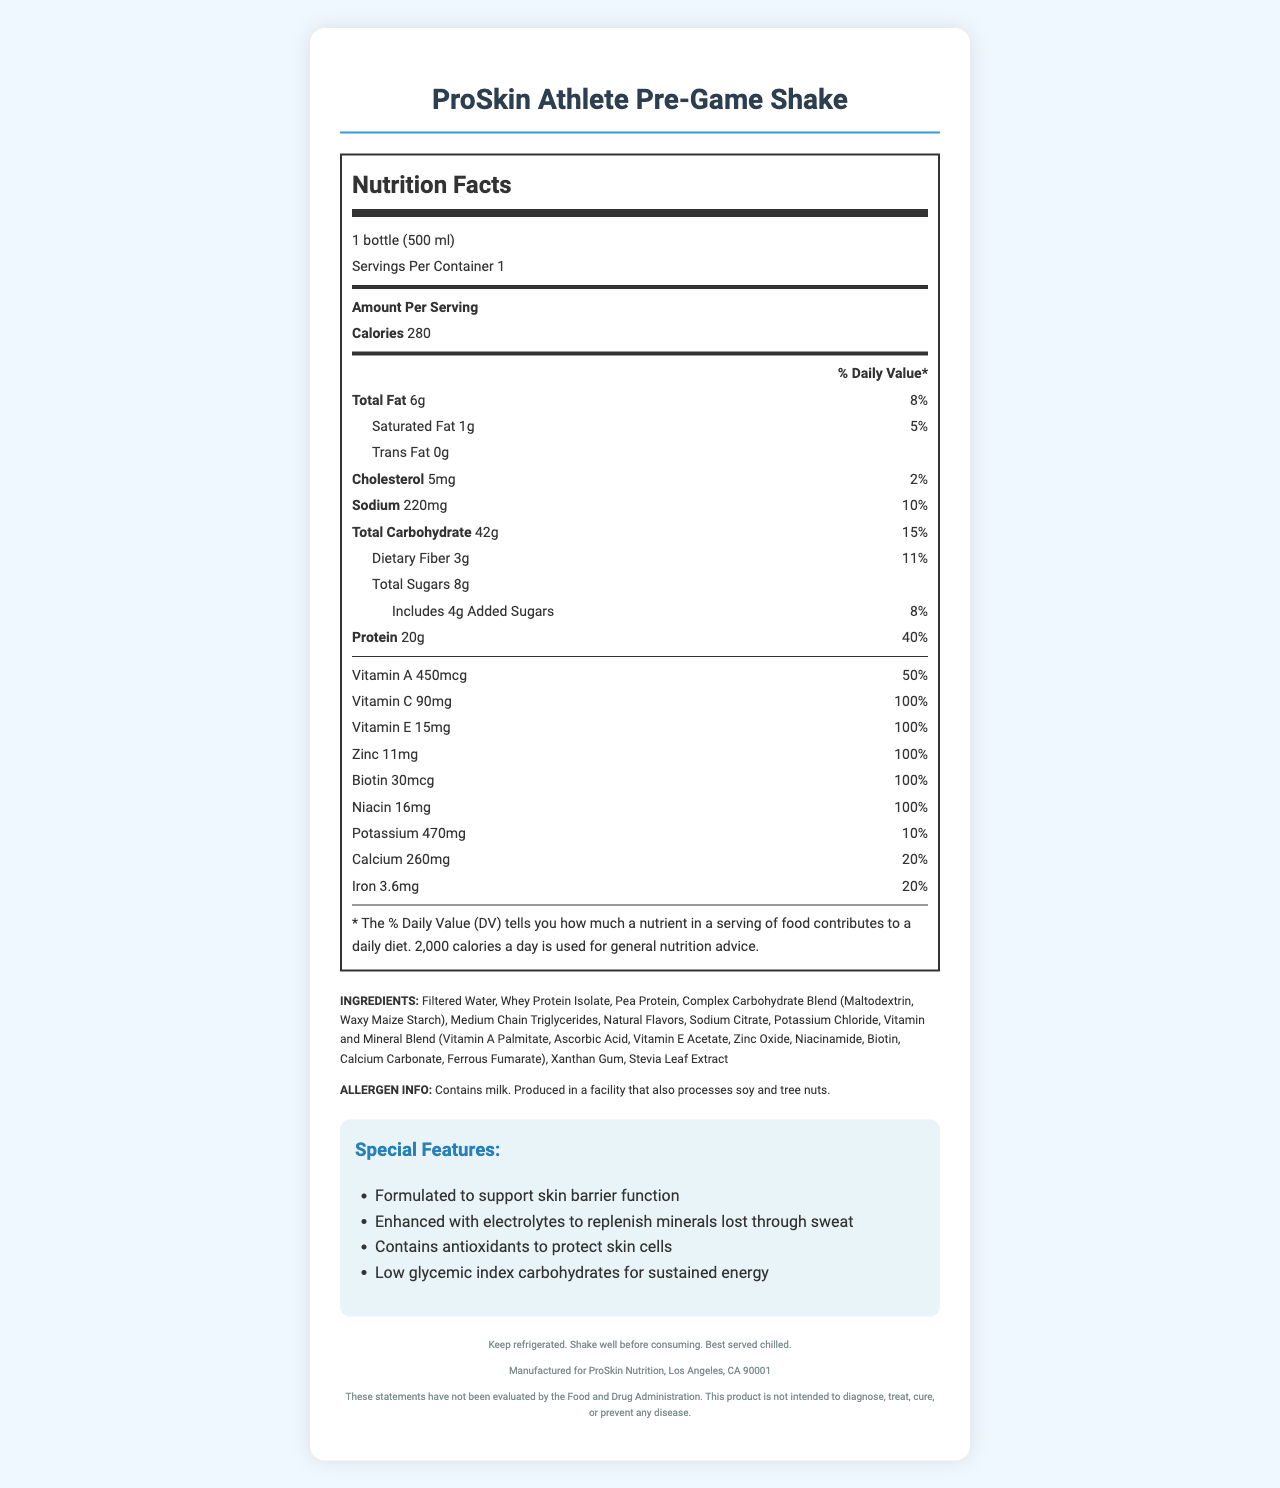What is the serving size of the ProSkin Athlete Pre-Game Shake? The document lists the serving size as 1 bottle (500 ml).
Answer: 1 bottle (500 ml) How many grams of total fat are in one serving? The amount of total fat per serving is specified as 6 grams in the document.
Answer: 6g What percentage of daily value does the protein content in one serving provide? The document states that the protein content is 20 grams, which is 40% of the daily value.
Answer: 40% Does the ProSkin Athlete Pre-Game Shake contain any trans fat? The document indicates that the trans fat content is 0 grams.
Answer: No What are the ingredients of the ProSkin Athlete Pre-Game Shake? The ingredients list is clearly mentioned in the document.
Answer: Filtered Water, Whey Protein Isolate, Pea Protein, Complex Carbohydrate Blend (Maltodextrin, Waxy Maize Starch), Medium Chain Triglycerides, Natural Flavors, Sodium Citrate, Potassium Chloride, Vitamin and Mineral Blend (Vitamin A Palmitate, Ascorbic Acid, Vitamin E Acetate, Zinc Oxide, Niacinamide, Biotin, Calcium Carbonate, Ferrous Fumarate), Xanthan Gum, Stevia Leaf Extract What is the total carbohydrate content and its daily value percentage? The total carbohydrate content is listed as 42 grams with a daily value percentage of 15%.
Answer: 42g, 15% Which of the following vitamins and minerals in the shake have a 100% daily value? A. Vitamin A B. Vitamin C C. Iron D. Niacin The document shows Vitamin C, Vitamin E, Zinc, Biotin, and Niacin have a 100% daily value.
Answer: B, D How much sodium is present in the shake, and what is its daily value percentage? The sodium content is 220 milligrams, which corresponds to 10% of the daily value.
Answer: 220mg, 10% Does the shake contain any dairy allergens? True or False The allergen information states that it contains milk.
Answer: True What are some special features of the ProSkin Athlete Pre-Game Shake? The document lists four special features under a separate section named "Special Features".
Answer: Formulated to support skin barrier function, Enhanced with electrolytes to replenish minerals lost through sweat, Contains antioxidants to protect skin cells, Low glycemic index carbohydrates for sustained energy Where is the ProSkin Athlete Pre-Game Shake manufactured? The manufacturer info at the bottom of the document mentions ProSkin Nutrition, Los Angeles, CA 90001.
Answer: Los Angeles, CA 90001 Summarize the main purpose and benefits of the ProSkin Athlete Pre-Game Shake. This summary encapsulates the nutritional content, purpose, and special features of the shake as conveyed in the document.
Answer: The ProSkin Athlete Pre-Game Shake is designed for athletes, specifically formulated to prevent excessive sweating and support skin barrier function. It provides a balanced nutrition profile with proteins, carbohydrates, essential vitamins, and minerals. It is enriched with electrolytes, antioxidants, and low glycemic index carbohydrates to support sustained energy, hydration, and skin health. Is there information about the price of the ProSkin Athlete Pre-Game Shake in the document? The document does not specify the price of the product.
Answer: Not enough information 